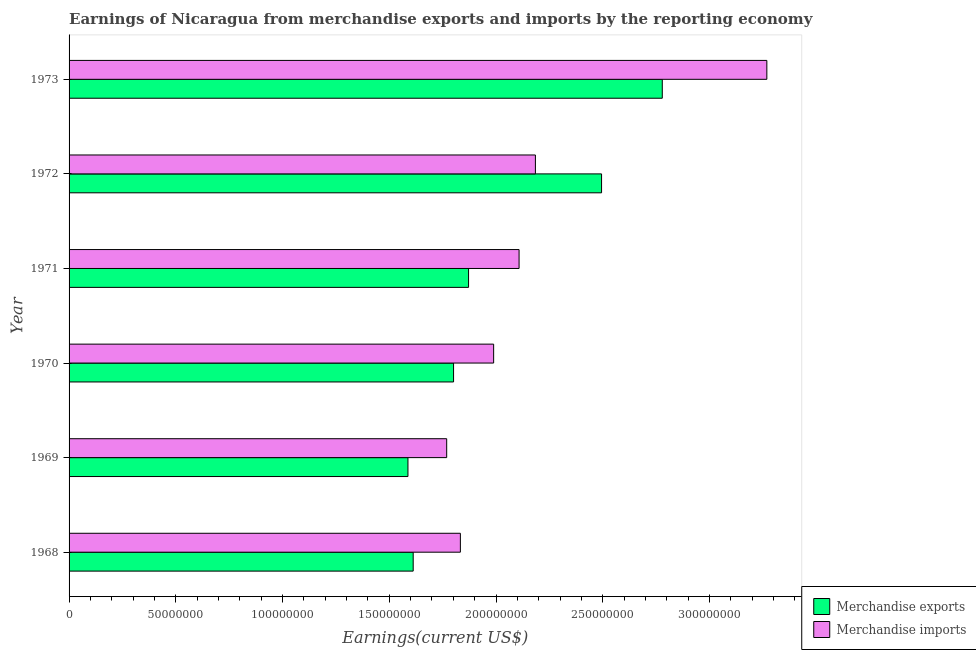How many groups of bars are there?
Provide a succinct answer. 6. Are the number of bars per tick equal to the number of legend labels?
Provide a short and direct response. Yes. Are the number of bars on each tick of the Y-axis equal?
Make the answer very short. Yes. What is the earnings from merchandise exports in 1973?
Ensure brevity in your answer.  2.78e+08. Across all years, what is the maximum earnings from merchandise imports?
Make the answer very short. 3.27e+08. Across all years, what is the minimum earnings from merchandise exports?
Your answer should be very brief. 1.59e+08. In which year was the earnings from merchandise exports minimum?
Your answer should be very brief. 1969. What is the total earnings from merchandise exports in the graph?
Offer a terse response. 1.21e+09. What is the difference between the earnings from merchandise exports in 1969 and that in 1972?
Ensure brevity in your answer.  -9.07e+07. What is the difference between the earnings from merchandise exports in 1968 and the earnings from merchandise imports in 1970?
Give a very brief answer. -3.77e+07. What is the average earnings from merchandise exports per year?
Make the answer very short. 2.02e+08. In the year 1968, what is the difference between the earnings from merchandise imports and earnings from merchandise exports?
Your answer should be compact. 2.21e+07. In how many years, is the earnings from merchandise exports greater than 310000000 US$?
Offer a very short reply. 0. What is the ratio of the earnings from merchandise exports in 1970 to that in 1973?
Your answer should be very brief. 0.65. Is the earnings from merchandise exports in 1970 less than that in 1973?
Your response must be concise. Yes. What is the difference between the highest and the second highest earnings from merchandise exports?
Your answer should be very brief. 2.84e+07. What is the difference between the highest and the lowest earnings from merchandise exports?
Keep it short and to the point. 1.19e+08. In how many years, is the earnings from merchandise exports greater than the average earnings from merchandise exports taken over all years?
Your answer should be very brief. 2. Is the sum of the earnings from merchandise imports in 1968 and 1970 greater than the maximum earnings from merchandise exports across all years?
Your answer should be very brief. Yes. Are all the bars in the graph horizontal?
Your response must be concise. Yes. How many years are there in the graph?
Keep it short and to the point. 6. Does the graph contain any zero values?
Your answer should be very brief. No. Does the graph contain grids?
Offer a terse response. No. How are the legend labels stacked?
Give a very brief answer. Vertical. What is the title of the graph?
Give a very brief answer. Earnings of Nicaragua from merchandise exports and imports by the reporting economy. Does "Female" appear as one of the legend labels in the graph?
Your answer should be very brief. No. What is the label or title of the X-axis?
Your answer should be very brief. Earnings(current US$). What is the label or title of the Y-axis?
Keep it short and to the point. Year. What is the Earnings(current US$) of Merchandise exports in 1968?
Provide a succinct answer. 1.61e+08. What is the Earnings(current US$) of Merchandise imports in 1968?
Offer a very short reply. 1.83e+08. What is the Earnings(current US$) of Merchandise exports in 1969?
Ensure brevity in your answer.  1.59e+08. What is the Earnings(current US$) of Merchandise imports in 1969?
Offer a very short reply. 1.77e+08. What is the Earnings(current US$) in Merchandise exports in 1970?
Make the answer very short. 1.80e+08. What is the Earnings(current US$) in Merchandise imports in 1970?
Provide a succinct answer. 1.99e+08. What is the Earnings(current US$) in Merchandise exports in 1971?
Keep it short and to the point. 1.87e+08. What is the Earnings(current US$) in Merchandise imports in 1971?
Ensure brevity in your answer.  2.11e+08. What is the Earnings(current US$) of Merchandise exports in 1972?
Give a very brief answer. 2.49e+08. What is the Earnings(current US$) in Merchandise imports in 1972?
Give a very brief answer. 2.18e+08. What is the Earnings(current US$) of Merchandise exports in 1973?
Offer a very short reply. 2.78e+08. What is the Earnings(current US$) of Merchandise imports in 1973?
Provide a succinct answer. 3.27e+08. Across all years, what is the maximum Earnings(current US$) in Merchandise exports?
Your answer should be very brief. 2.78e+08. Across all years, what is the maximum Earnings(current US$) in Merchandise imports?
Your answer should be compact. 3.27e+08. Across all years, what is the minimum Earnings(current US$) of Merchandise exports?
Offer a terse response. 1.59e+08. Across all years, what is the minimum Earnings(current US$) of Merchandise imports?
Ensure brevity in your answer.  1.77e+08. What is the total Earnings(current US$) in Merchandise exports in the graph?
Offer a terse response. 1.21e+09. What is the total Earnings(current US$) of Merchandise imports in the graph?
Offer a very short reply. 1.32e+09. What is the difference between the Earnings(current US$) in Merchandise exports in 1968 and that in 1969?
Provide a succinct answer. 2.45e+06. What is the difference between the Earnings(current US$) in Merchandise imports in 1968 and that in 1969?
Your response must be concise. 6.41e+06. What is the difference between the Earnings(current US$) of Merchandise exports in 1968 and that in 1970?
Your answer should be compact. -1.89e+07. What is the difference between the Earnings(current US$) of Merchandise imports in 1968 and that in 1970?
Offer a very short reply. -1.56e+07. What is the difference between the Earnings(current US$) in Merchandise exports in 1968 and that in 1971?
Your response must be concise. -2.59e+07. What is the difference between the Earnings(current US$) in Merchandise imports in 1968 and that in 1971?
Your response must be concise. -2.75e+07. What is the difference between the Earnings(current US$) of Merchandise exports in 1968 and that in 1972?
Your response must be concise. -8.82e+07. What is the difference between the Earnings(current US$) of Merchandise imports in 1968 and that in 1972?
Make the answer very short. -3.52e+07. What is the difference between the Earnings(current US$) of Merchandise exports in 1968 and that in 1973?
Offer a very short reply. -1.17e+08. What is the difference between the Earnings(current US$) of Merchandise imports in 1968 and that in 1973?
Your answer should be very brief. -1.44e+08. What is the difference between the Earnings(current US$) of Merchandise exports in 1969 and that in 1970?
Your answer should be compact. -2.14e+07. What is the difference between the Earnings(current US$) in Merchandise imports in 1969 and that in 1970?
Give a very brief answer. -2.20e+07. What is the difference between the Earnings(current US$) of Merchandise exports in 1969 and that in 1971?
Provide a succinct answer. -2.84e+07. What is the difference between the Earnings(current US$) of Merchandise imports in 1969 and that in 1971?
Offer a very short reply. -3.39e+07. What is the difference between the Earnings(current US$) of Merchandise exports in 1969 and that in 1972?
Ensure brevity in your answer.  -9.07e+07. What is the difference between the Earnings(current US$) in Merchandise imports in 1969 and that in 1972?
Keep it short and to the point. -4.16e+07. What is the difference between the Earnings(current US$) of Merchandise exports in 1969 and that in 1973?
Your answer should be very brief. -1.19e+08. What is the difference between the Earnings(current US$) of Merchandise imports in 1969 and that in 1973?
Provide a succinct answer. -1.50e+08. What is the difference between the Earnings(current US$) of Merchandise exports in 1970 and that in 1971?
Your response must be concise. -7.02e+06. What is the difference between the Earnings(current US$) of Merchandise imports in 1970 and that in 1971?
Your answer should be compact. -1.19e+07. What is the difference between the Earnings(current US$) of Merchandise exports in 1970 and that in 1972?
Give a very brief answer. -6.93e+07. What is the difference between the Earnings(current US$) in Merchandise imports in 1970 and that in 1972?
Make the answer very short. -1.96e+07. What is the difference between the Earnings(current US$) of Merchandise exports in 1970 and that in 1973?
Your response must be concise. -9.78e+07. What is the difference between the Earnings(current US$) in Merchandise imports in 1970 and that in 1973?
Give a very brief answer. -1.28e+08. What is the difference between the Earnings(current US$) of Merchandise exports in 1971 and that in 1972?
Provide a short and direct response. -6.23e+07. What is the difference between the Earnings(current US$) of Merchandise imports in 1971 and that in 1972?
Give a very brief answer. -7.65e+06. What is the difference between the Earnings(current US$) in Merchandise exports in 1971 and that in 1973?
Offer a very short reply. -9.07e+07. What is the difference between the Earnings(current US$) of Merchandise imports in 1971 and that in 1973?
Offer a very short reply. -1.16e+08. What is the difference between the Earnings(current US$) of Merchandise exports in 1972 and that in 1973?
Offer a terse response. -2.84e+07. What is the difference between the Earnings(current US$) in Merchandise imports in 1972 and that in 1973?
Offer a terse response. -1.08e+08. What is the difference between the Earnings(current US$) in Merchandise exports in 1968 and the Earnings(current US$) in Merchandise imports in 1969?
Offer a terse response. -1.57e+07. What is the difference between the Earnings(current US$) in Merchandise exports in 1968 and the Earnings(current US$) in Merchandise imports in 1970?
Provide a succinct answer. -3.77e+07. What is the difference between the Earnings(current US$) of Merchandise exports in 1968 and the Earnings(current US$) of Merchandise imports in 1971?
Ensure brevity in your answer.  -4.96e+07. What is the difference between the Earnings(current US$) of Merchandise exports in 1968 and the Earnings(current US$) of Merchandise imports in 1972?
Make the answer very short. -5.72e+07. What is the difference between the Earnings(current US$) of Merchandise exports in 1968 and the Earnings(current US$) of Merchandise imports in 1973?
Provide a succinct answer. -1.66e+08. What is the difference between the Earnings(current US$) of Merchandise exports in 1969 and the Earnings(current US$) of Merchandise imports in 1970?
Make the answer very short. -4.01e+07. What is the difference between the Earnings(current US$) in Merchandise exports in 1969 and the Earnings(current US$) in Merchandise imports in 1971?
Keep it short and to the point. -5.21e+07. What is the difference between the Earnings(current US$) in Merchandise exports in 1969 and the Earnings(current US$) in Merchandise imports in 1972?
Your answer should be compact. -5.97e+07. What is the difference between the Earnings(current US$) of Merchandise exports in 1969 and the Earnings(current US$) of Merchandise imports in 1973?
Ensure brevity in your answer.  -1.68e+08. What is the difference between the Earnings(current US$) of Merchandise exports in 1970 and the Earnings(current US$) of Merchandise imports in 1971?
Offer a terse response. -3.07e+07. What is the difference between the Earnings(current US$) in Merchandise exports in 1970 and the Earnings(current US$) in Merchandise imports in 1972?
Offer a terse response. -3.83e+07. What is the difference between the Earnings(current US$) in Merchandise exports in 1970 and the Earnings(current US$) in Merchandise imports in 1973?
Your response must be concise. -1.47e+08. What is the difference between the Earnings(current US$) of Merchandise exports in 1971 and the Earnings(current US$) of Merchandise imports in 1972?
Offer a very short reply. -3.13e+07. What is the difference between the Earnings(current US$) in Merchandise exports in 1971 and the Earnings(current US$) in Merchandise imports in 1973?
Your answer should be very brief. -1.40e+08. What is the difference between the Earnings(current US$) of Merchandise exports in 1972 and the Earnings(current US$) of Merchandise imports in 1973?
Give a very brief answer. -7.74e+07. What is the average Earnings(current US$) in Merchandise exports per year?
Provide a short and direct response. 2.02e+08. What is the average Earnings(current US$) of Merchandise imports per year?
Ensure brevity in your answer.  2.19e+08. In the year 1968, what is the difference between the Earnings(current US$) of Merchandise exports and Earnings(current US$) of Merchandise imports?
Keep it short and to the point. -2.21e+07. In the year 1969, what is the difference between the Earnings(current US$) in Merchandise exports and Earnings(current US$) in Merchandise imports?
Give a very brief answer. -1.81e+07. In the year 1970, what is the difference between the Earnings(current US$) of Merchandise exports and Earnings(current US$) of Merchandise imports?
Offer a terse response. -1.88e+07. In the year 1971, what is the difference between the Earnings(current US$) in Merchandise exports and Earnings(current US$) in Merchandise imports?
Your answer should be compact. -2.37e+07. In the year 1972, what is the difference between the Earnings(current US$) in Merchandise exports and Earnings(current US$) in Merchandise imports?
Ensure brevity in your answer.  3.10e+07. In the year 1973, what is the difference between the Earnings(current US$) in Merchandise exports and Earnings(current US$) in Merchandise imports?
Keep it short and to the point. -4.90e+07. What is the ratio of the Earnings(current US$) in Merchandise exports in 1968 to that in 1969?
Give a very brief answer. 1.02. What is the ratio of the Earnings(current US$) of Merchandise imports in 1968 to that in 1969?
Provide a succinct answer. 1.04. What is the ratio of the Earnings(current US$) in Merchandise exports in 1968 to that in 1970?
Provide a succinct answer. 0.9. What is the ratio of the Earnings(current US$) of Merchandise imports in 1968 to that in 1970?
Give a very brief answer. 0.92. What is the ratio of the Earnings(current US$) of Merchandise exports in 1968 to that in 1971?
Your response must be concise. 0.86. What is the ratio of the Earnings(current US$) in Merchandise imports in 1968 to that in 1971?
Ensure brevity in your answer.  0.87. What is the ratio of the Earnings(current US$) in Merchandise exports in 1968 to that in 1972?
Provide a short and direct response. 0.65. What is the ratio of the Earnings(current US$) in Merchandise imports in 1968 to that in 1972?
Offer a very short reply. 0.84. What is the ratio of the Earnings(current US$) in Merchandise exports in 1968 to that in 1973?
Your response must be concise. 0.58. What is the ratio of the Earnings(current US$) in Merchandise imports in 1968 to that in 1973?
Your answer should be compact. 0.56. What is the ratio of the Earnings(current US$) in Merchandise exports in 1969 to that in 1970?
Provide a succinct answer. 0.88. What is the ratio of the Earnings(current US$) in Merchandise imports in 1969 to that in 1970?
Make the answer very short. 0.89. What is the ratio of the Earnings(current US$) in Merchandise exports in 1969 to that in 1971?
Offer a very short reply. 0.85. What is the ratio of the Earnings(current US$) of Merchandise imports in 1969 to that in 1971?
Keep it short and to the point. 0.84. What is the ratio of the Earnings(current US$) in Merchandise exports in 1969 to that in 1972?
Keep it short and to the point. 0.64. What is the ratio of the Earnings(current US$) of Merchandise imports in 1969 to that in 1972?
Your response must be concise. 0.81. What is the ratio of the Earnings(current US$) in Merchandise exports in 1969 to that in 1973?
Offer a terse response. 0.57. What is the ratio of the Earnings(current US$) in Merchandise imports in 1969 to that in 1973?
Make the answer very short. 0.54. What is the ratio of the Earnings(current US$) of Merchandise exports in 1970 to that in 1971?
Your answer should be compact. 0.96. What is the ratio of the Earnings(current US$) of Merchandise imports in 1970 to that in 1971?
Ensure brevity in your answer.  0.94. What is the ratio of the Earnings(current US$) of Merchandise exports in 1970 to that in 1972?
Your answer should be very brief. 0.72. What is the ratio of the Earnings(current US$) in Merchandise imports in 1970 to that in 1972?
Provide a succinct answer. 0.91. What is the ratio of the Earnings(current US$) of Merchandise exports in 1970 to that in 1973?
Your answer should be compact. 0.65. What is the ratio of the Earnings(current US$) of Merchandise imports in 1970 to that in 1973?
Make the answer very short. 0.61. What is the ratio of the Earnings(current US$) in Merchandise exports in 1971 to that in 1972?
Your answer should be compact. 0.75. What is the ratio of the Earnings(current US$) in Merchandise exports in 1971 to that in 1973?
Give a very brief answer. 0.67. What is the ratio of the Earnings(current US$) of Merchandise imports in 1971 to that in 1973?
Provide a short and direct response. 0.64. What is the ratio of the Earnings(current US$) of Merchandise exports in 1972 to that in 1973?
Make the answer very short. 0.9. What is the ratio of the Earnings(current US$) of Merchandise imports in 1972 to that in 1973?
Your answer should be very brief. 0.67. What is the difference between the highest and the second highest Earnings(current US$) of Merchandise exports?
Keep it short and to the point. 2.84e+07. What is the difference between the highest and the second highest Earnings(current US$) of Merchandise imports?
Your response must be concise. 1.08e+08. What is the difference between the highest and the lowest Earnings(current US$) in Merchandise exports?
Make the answer very short. 1.19e+08. What is the difference between the highest and the lowest Earnings(current US$) of Merchandise imports?
Ensure brevity in your answer.  1.50e+08. 